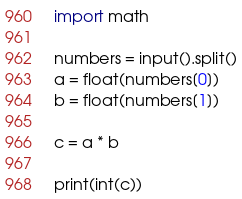Convert code to text. <code><loc_0><loc_0><loc_500><loc_500><_Python_>import math

numbers = input().split()
a = float(numbers[0])
b = float(numbers[1])

c = a * b

print(int(c))
</code> 